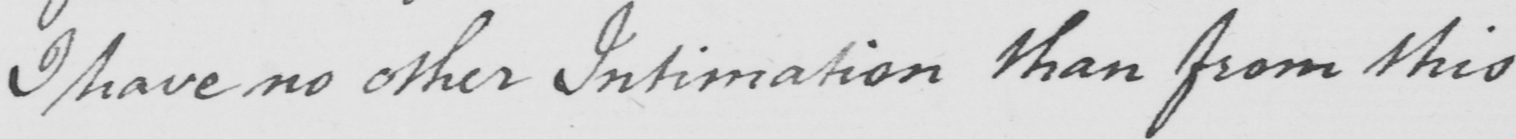Please provide the text content of this handwritten line. I have no other Intimation than from this 